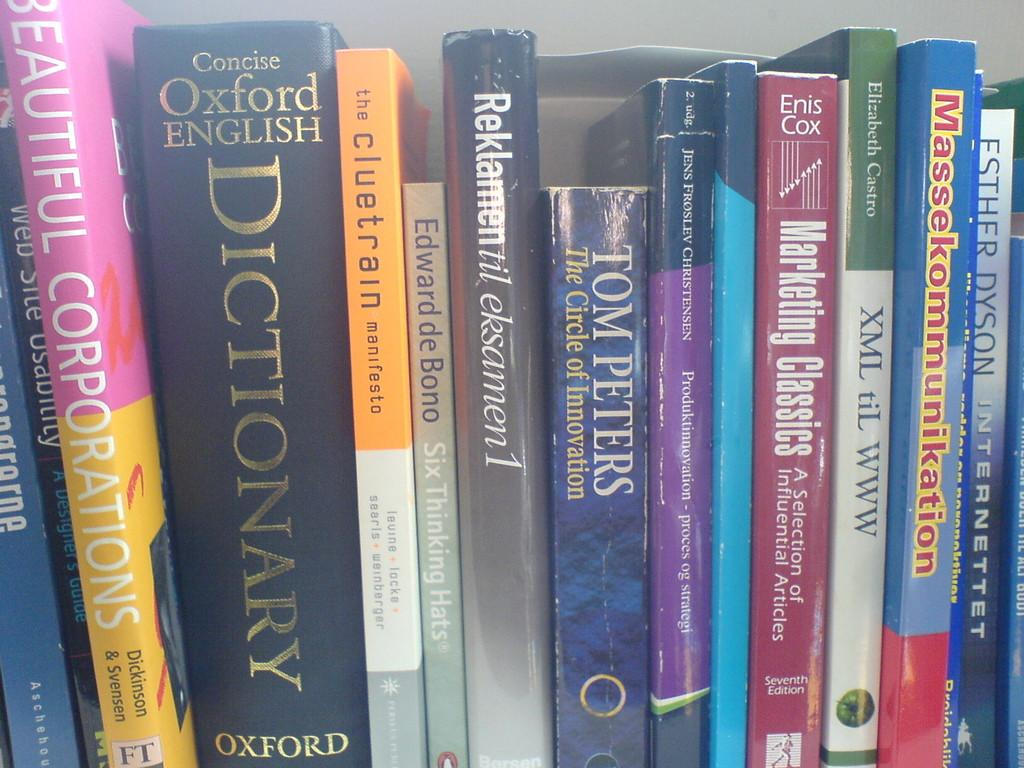<image>
Create a compact narrative representing the image presented. the name Tom Peters is on a book 